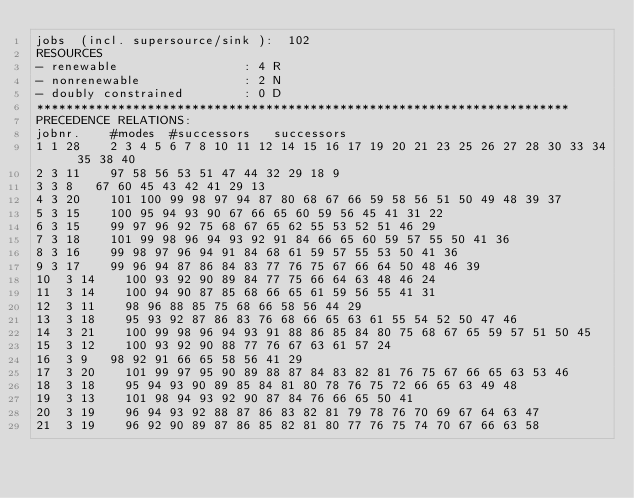Convert code to text. <code><loc_0><loc_0><loc_500><loc_500><_ObjectiveC_>jobs  (incl. supersource/sink ):	102
RESOURCES
- renewable                 : 4 R
- nonrenewable              : 2 N
- doubly constrained        : 0 D
************************************************************************
PRECEDENCE RELATIONS:
jobnr.    #modes  #successors   successors
1	1	28		2 3 4 5 6 7 8 10 11 12 14 15 16 17 19 20 21 23 25 26 27 28 30 33 34 35 38 40 
2	3	11		97 58 56 53 51 47 44 32 29 18 9 
3	3	8		67 60 45 43 42 41 29 13 
4	3	20		101 100 99 98 97 94 87 80 68 67 66 59 58 56 51 50 49 48 39 37 
5	3	15		100 95 94 93 90 67 66 65 60 59 56 45 41 31 22 
6	3	15		99 97 96 92 75 68 67 65 62 55 53 52 51 46 29 
7	3	18		101 99 98 96 94 93 92 91 84 66 65 60 59 57 55 50 41 36 
8	3	16		99 98 97 96 94 91 84 68 61 59 57 55 53 50 41 36 
9	3	17		99 96 94 87 86 84 83 77 76 75 67 66 64 50 48 46 39 
10	3	14		100 93 92 90 89 84 77 75 66 64 63 48 46 24 
11	3	14		100 94 90 87 85 68 66 65 61 59 56 55 41 31 
12	3	11		98 96 88 85 75 68 66 58 56 44 29 
13	3	18		95 93 92 87 86 83 76 68 66 65 63 61 55 54 52 50 47 46 
14	3	21		100 99 98 96 94 93 91 88 86 85 84 80 75 68 67 65 59 57 51 50 45 
15	3	12		100 93 92 90 88 77 76 67 63 61 57 24 
16	3	9		98 92 91 66 65 58 56 41 29 
17	3	20		101 99 97 95 90 89 88 87 84 83 82 81 76 75 67 66 65 63 53 46 
18	3	18		95 94 93 90 89 85 84 81 80 78 76 75 72 66 65 63 49 48 
19	3	13		101 98 94 93 92 90 87 84 76 66 65 50 41 
20	3	19		96 94 93 92 88 87 86 83 82 81 79 78 76 70 69 67 64 63 47 
21	3	19		96 92 90 89 87 86 85 82 81 80 77 76 75 74 70 67 66 63 58 </code> 